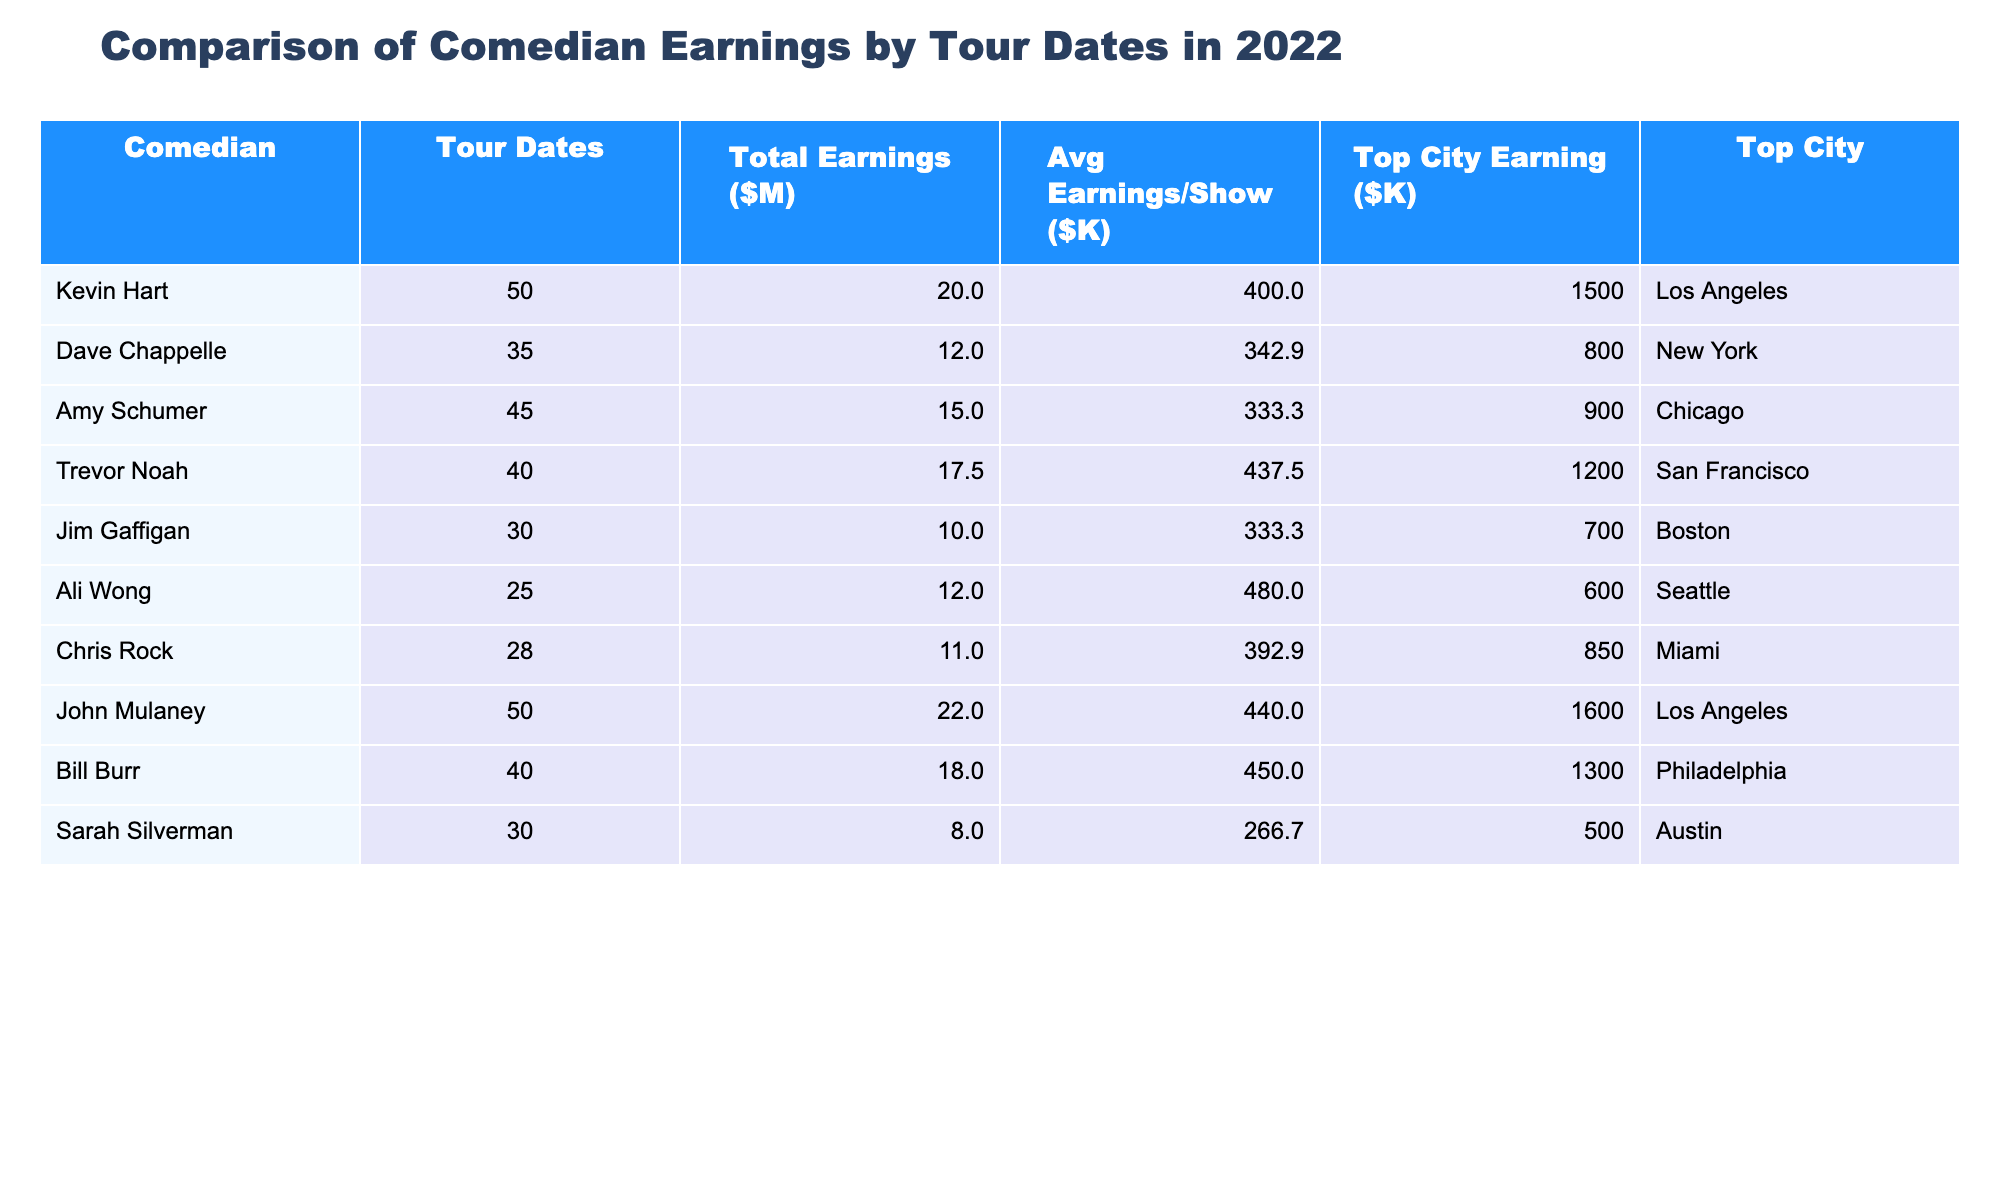What is the total earnings of John Mulaney? The total earnings for John Mulaney are stated in the table as $22,000,000.
Answer: 22000000 Which comedian has the highest average earnings per show? The table shows that John Mulaney has the highest average earnings per show at $440,000.
Answer: John Mulaney How many tour dates did Kevin Hart have? The table indicates that Kevin Hart had 50 tour dates.
Answer: 50 What is the top city earning for Dave Chappelle? According to the table, the top city earning for Dave Chappelle is $800,000, which is listed next to New York.
Answer: 800000 Which comedian had the least total earnings? The table reveals that Sarah Silverman had the least total earnings at $8,000,000.
Answer: Sarah Silverman What is the difference in total earnings between Trevor Noah and Jim Gaffigan? Trevor Noah earned $17,500,000, while Jim Gaffigan earned $10,000,000. The difference is $17,500,000 - $10,000,000 = $7,500,000.
Answer: 7500000 In which city did Kevin Hart earn the most? The table shows that Kevin Hart earned $1,500,000 in Los Angeles, which is his top city earning.
Answer: Los Angeles What is the average earnings per show for Amy Schumer? Amy Schumer's average earnings per show are listed in the table as $333,333.
Answer: 333333 How many total tour dates did comedians earn over $15,000,000? Analyzing the table, we find that Kevin Hart, John Mulaney, Trevor Noah, and Bill Burr earned over $15,000,000. They collectively had 50, 50, 40, and 40 tour dates respectively, totaling 180 tour dates.
Answer: 180 Which comedian had more tour dates, Ali Wong or Chris Rock? Comparing the tour dates listed, Ali Wong had 25 while Chris Rock had 28. Therefore, Chris Rock had more tour dates.
Answer: Chris Rock What is the average total earnings of all comedians listed in the table? The combined total earnings of all comedians add up to $137,000,000. Dividing this by the number of comedians (10) gives an average of $13,700,000.
Answer: 13700000 